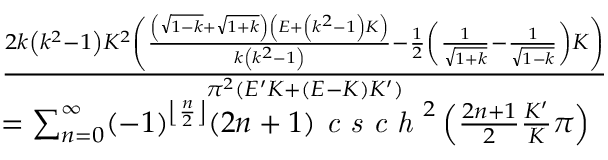<formula> <loc_0><loc_0><loc_500><loc_500>\begin{array} { r l } & { \frac { 2 k \left ( k ^ { 2 } - 1 \right ) K ^ { 2 } \left ( \frac { \left ( \sqrt { 1 - k } + \sqrt { 1 + k } \right ) \left ( E + \left ( k ^ { 2 } - 1 \right ) K \right ) } { k \left ( k ^ { 2 } - 1 \right ) } - \frac { 1 } { 2 } \left ( \frac { 1 } { \sqrt { 1 + k } } - \frac { 1 } { \sqrt { 1 - k } } \right ) K \right ) } { \pi ^ { 2 } ( E ^ { \prime } K + ( E - K ) K ^ { \prime } ) } } \\ & { = \sum _ { n = 0 } ^ { \infty } ( - 1 ) ^ { \left \lfloor \frac { n } { 2 } \right \rfloor } ( 2 n + 1 ) \emph { c s c h } ^ { 2 } \left ( \frac { 2 n + 1 } { 2 } \frac { K ^ { \prime } } { K } \pi \right ) } \end{array}</formula> 